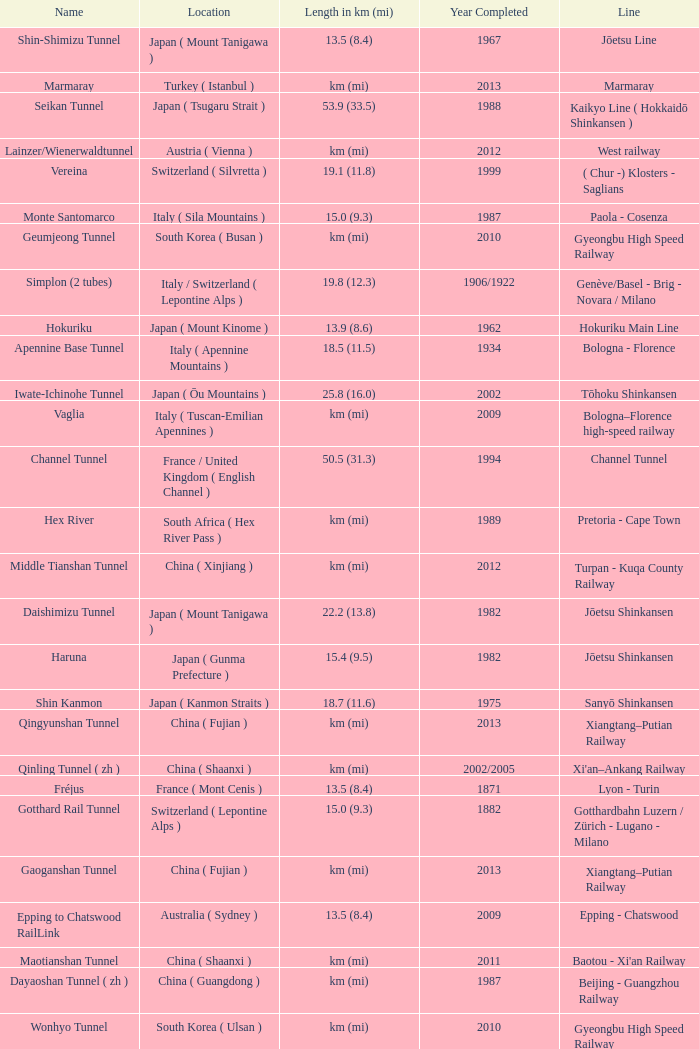Which line is the Geumjeong tunnel? Gyeongbu High Speed Railway. 